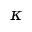<formula> <loc_0><loc_0><loc_500><loc_500>\kappa</formula> 